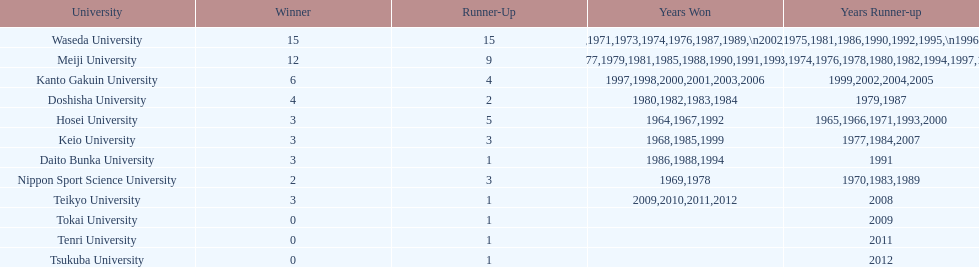Which university secured the most victories over the years? Waseda University. 